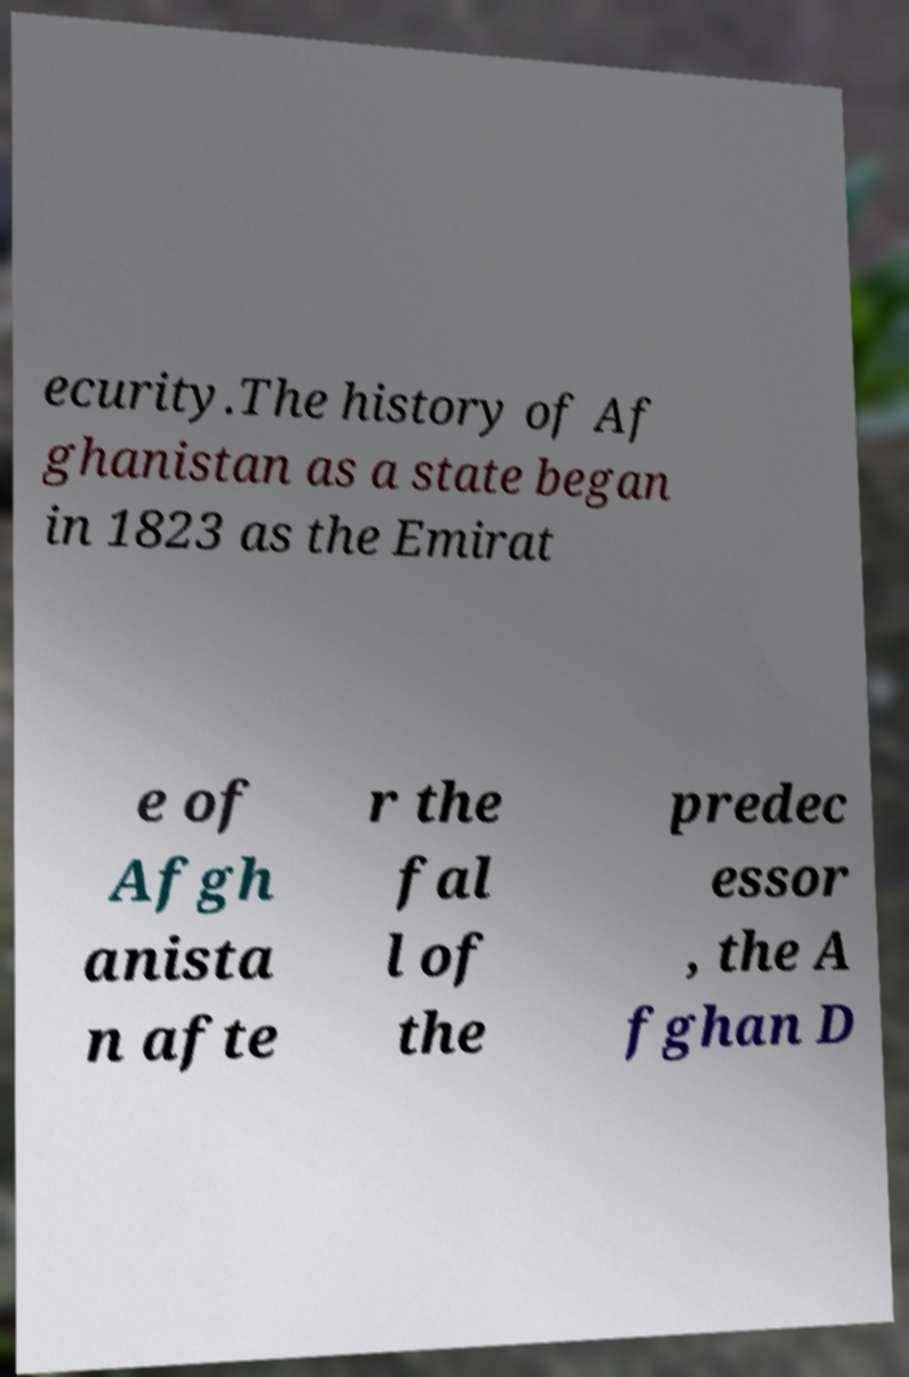I need the written content from this picture converted into text. Can you do that? ecurity.The history of Af ghanistan as a state began in 1823 as the Emirat e of Afgh anista n afte r the fal l of the predec essor , the A fghan D 